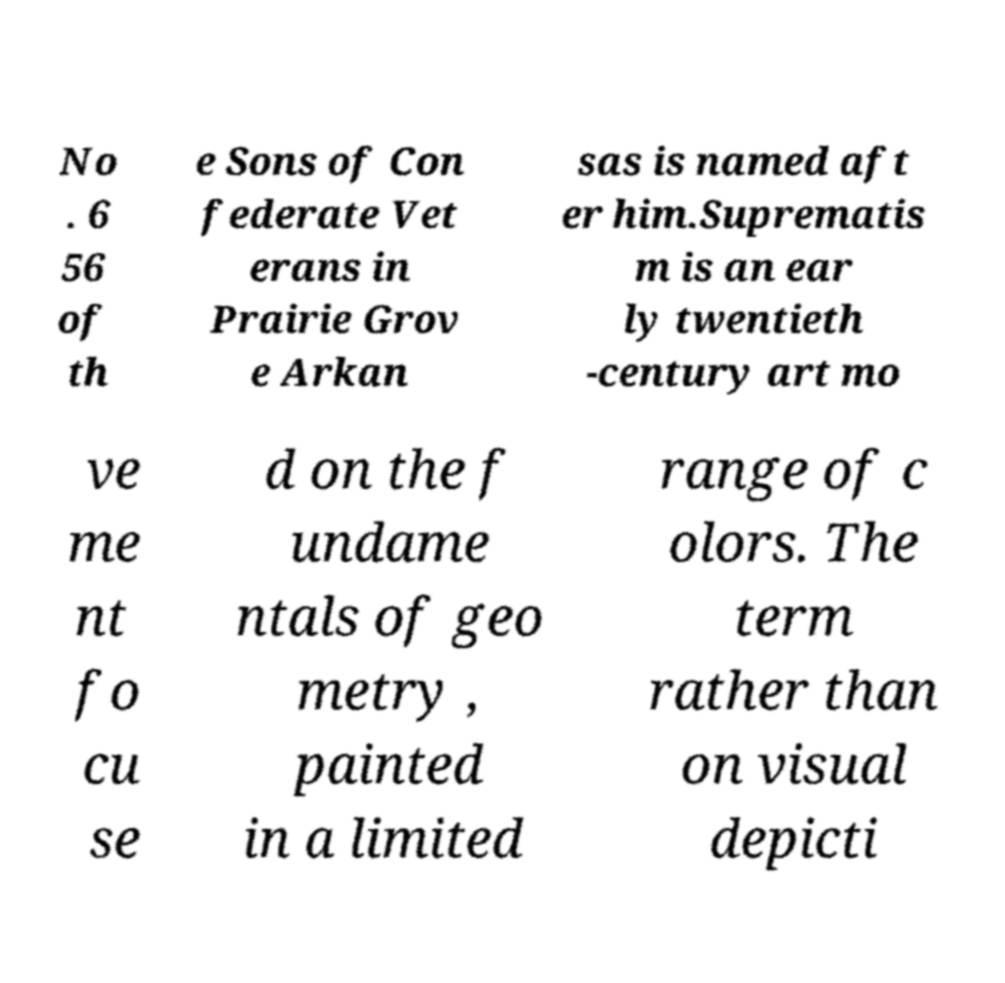There's text embedded in this image that I need extracted. Can you transcribe it verbatim? No . 6 56 of th e Sons of Con federate Vet erans in Prairie Grov e Arkan sas is named aft er him.Suprematis m is an ear ly twentieth -century art mo ve me nt fo cu se d on the f undame ntals of geo metry , painted in a limited range of c olors. The term rather than on visual depicti 